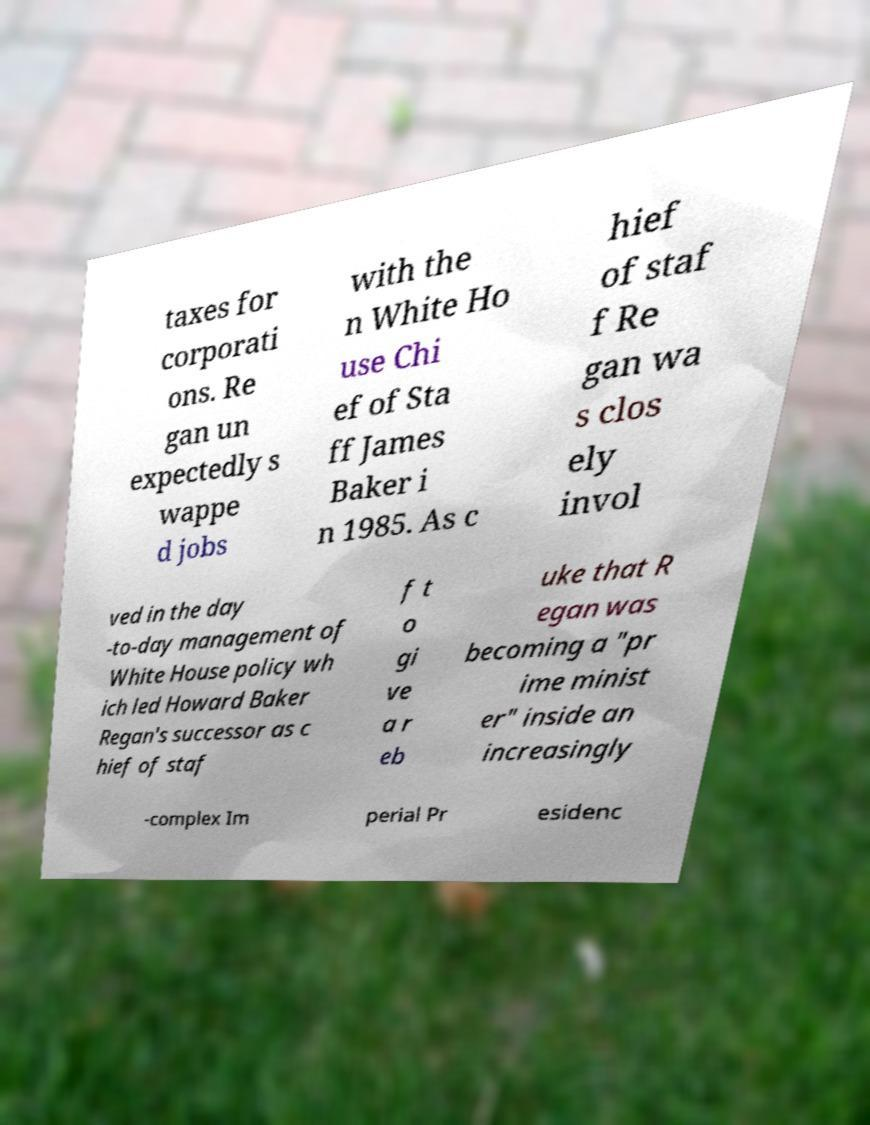I need the written content from this picture converted into text. Can you do that? taxes for corporati ons. Re gan un expectedly s wappe d jobs with the n White Ho use Chi ef of Sta ff James Baker i n 1985. As c hief of staf f Re gan wa s clos ely invol ved in the day -to-day management of White House policy wh ich led Howard Baker Regan's successor as c hief of staf f t o gi ve a r eb uke that R egan was becoming a "pr ime minist er" inside an increasingly -complex Im perial Pr esidenc 